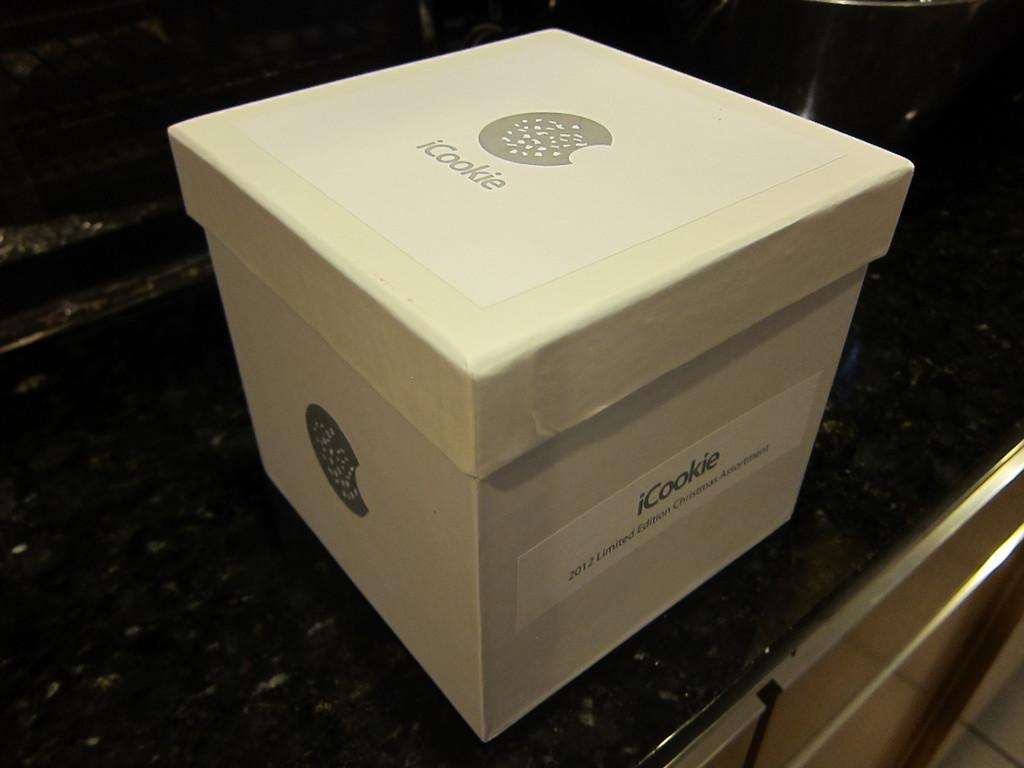<image>
Summarize the visual content of the image. A box that contains a 2012 limited edition iCookie Christmas assortment. 